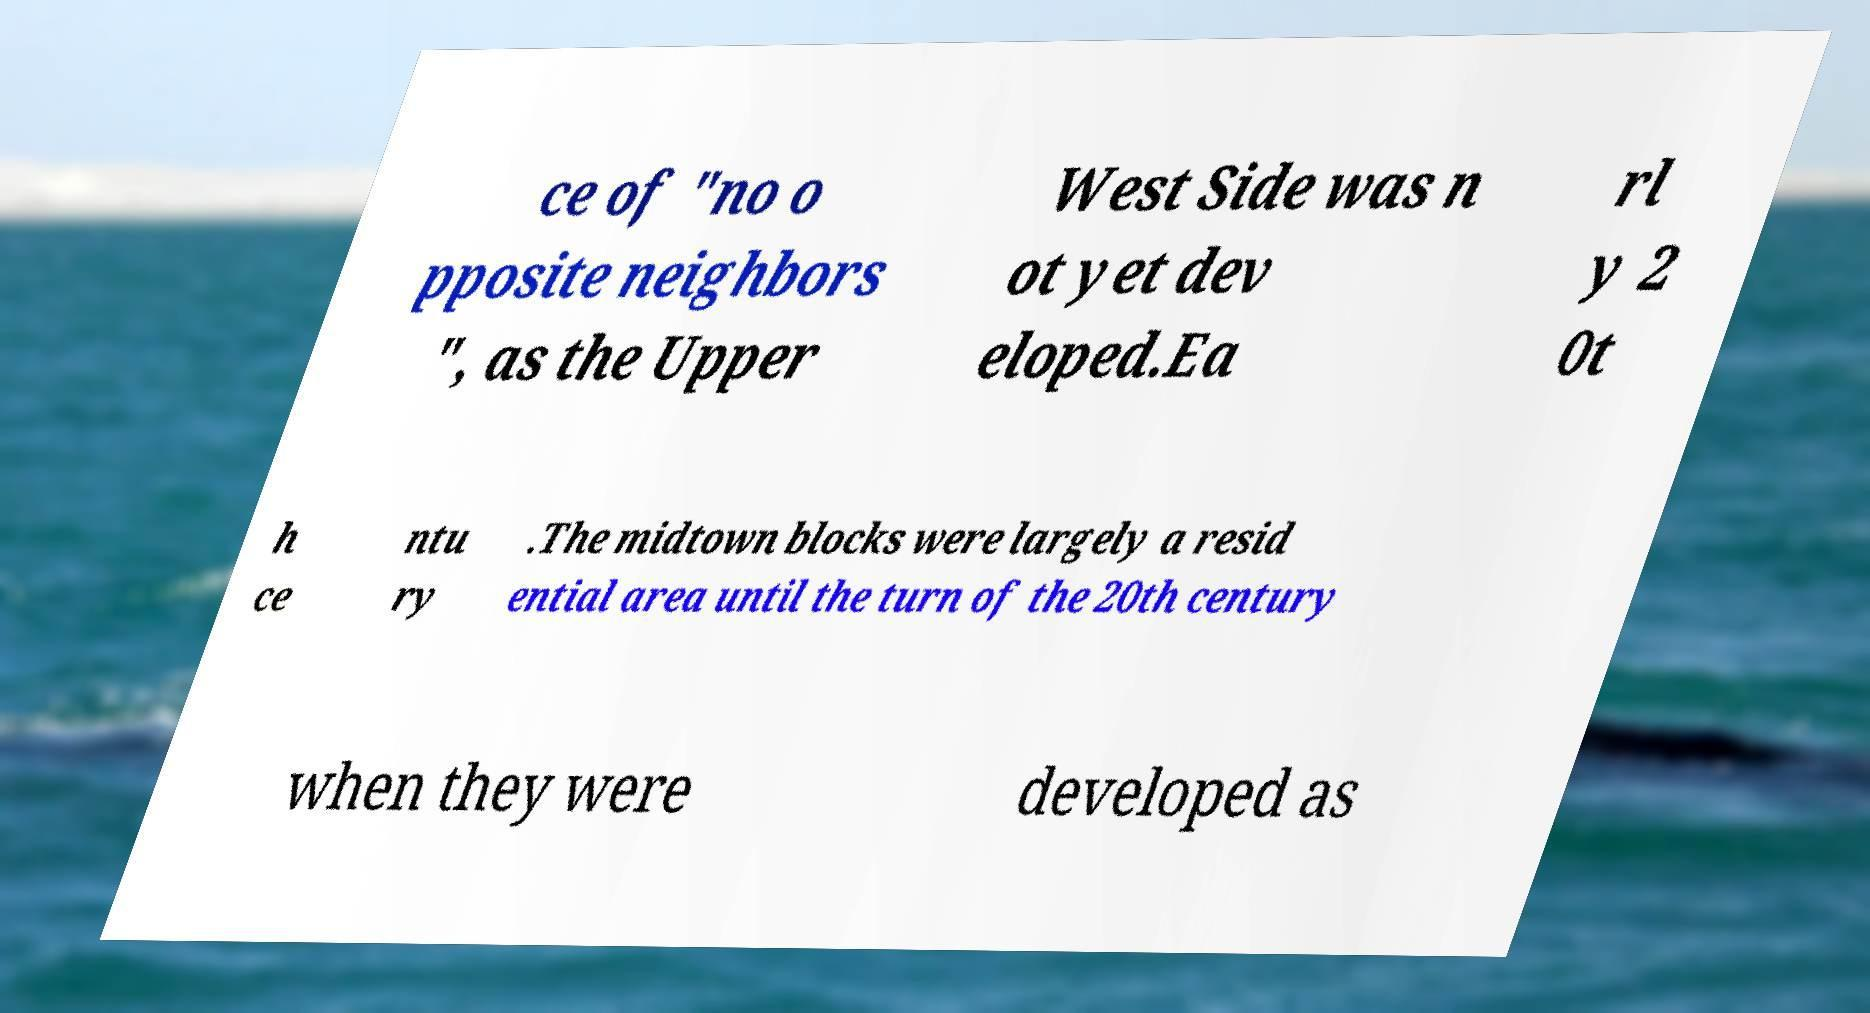Can you accurately transcribe the text from the provided image for me? ce of "no o pposite neighbors ", as the Upper West Side was n ot yet dev eloped.Ea rl y 2 0t h ce ntu ry .The midtown blocks were largely a resid ential area until the turn of the 20th century when they were developed as 